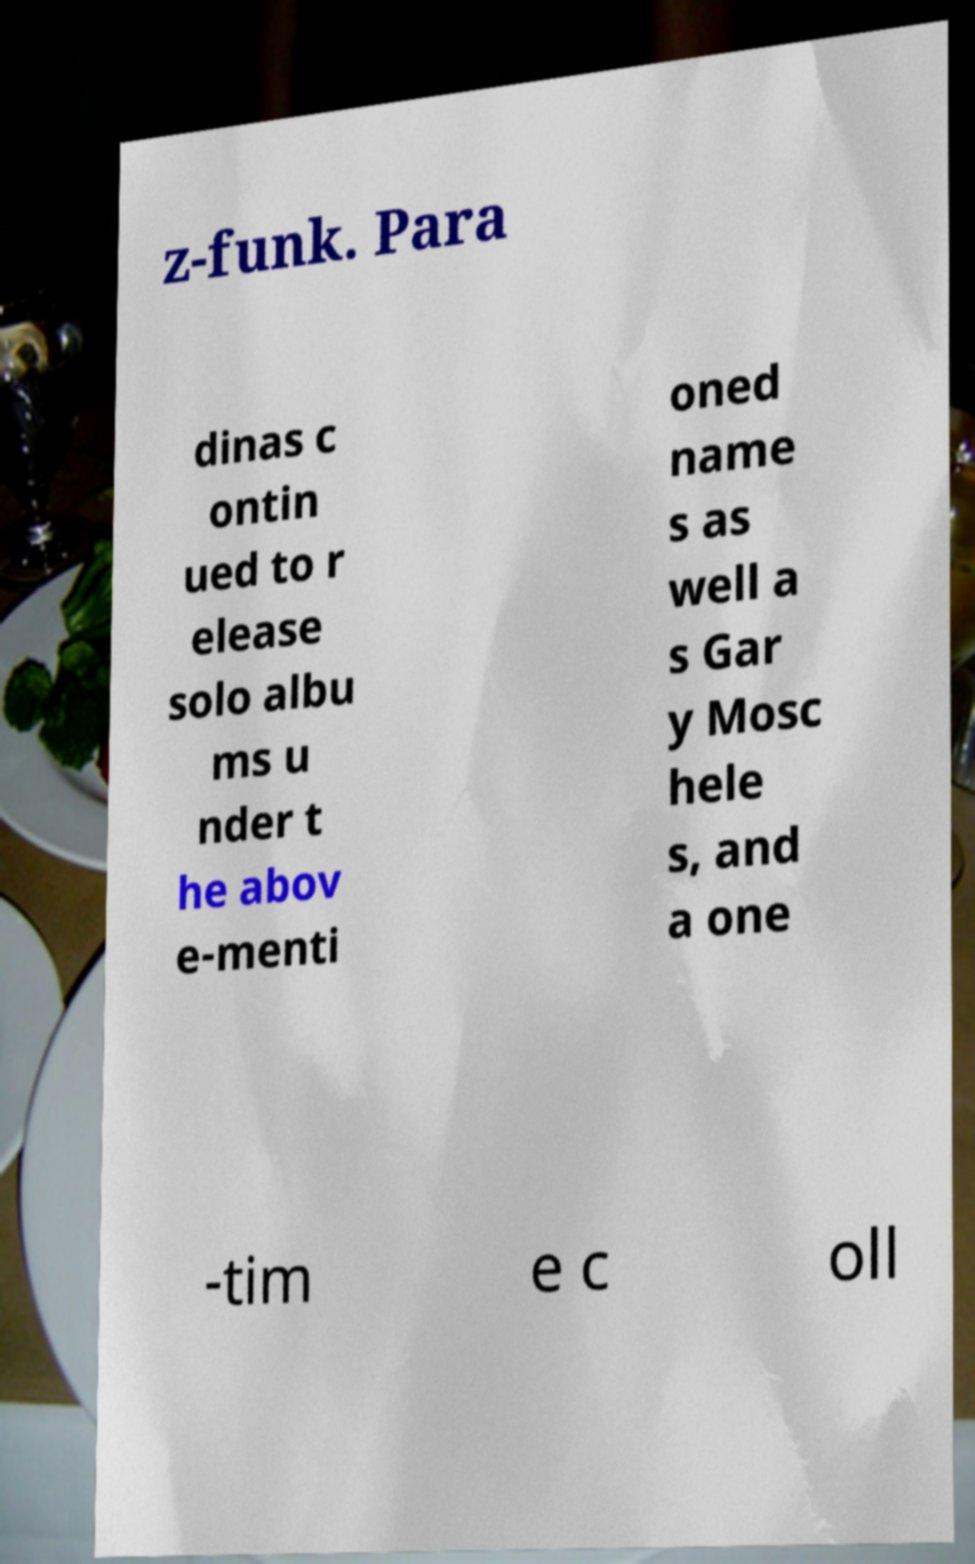I need the written content from this picture converted into text. Can you do that? z-funk. Para dinas c ontin ued to r elease solo albu ms u nder t he abov e-menti oned name s as well a s Gar y Mosc hele s, and a one -tim e c oll 